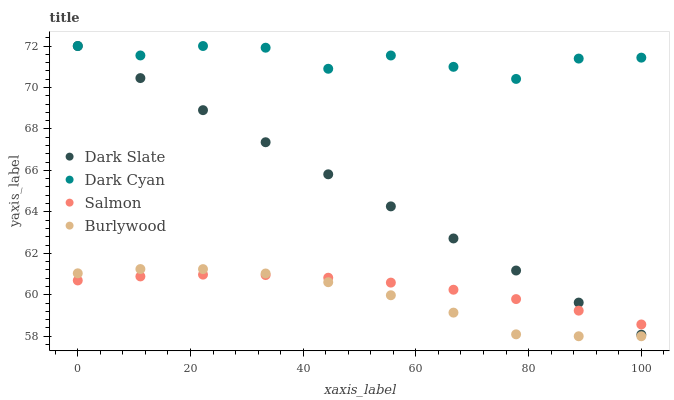Does Burlywood have the minimum area under the curve?
Answer yes or no. Yes. Does Dark Cyan have the maximum area under the curve?
Answer yes or no. Yes. Does Dark Slate have the minimum area under the curve?
Answer yes or no. No. Does Dark Slate have the maximum area under the curve?
Answer yes or no. No. Is Dark Slate the smoothest?
Answer yes or no. Yes. Is Dark Cyan the roughest?
Answer yes or no. Yes. Is Salmon the smoothest?
Answer yes or no. No. Is Salmon the roughest?
Answer yes or no. No. Does Burlywood have the lowest value?
Answer yes or no. Yes. Does Dark Slate have the lowest value?
Answer yes or no. No. Does Dark Slate have the highest value?
Answer yes or no. Yes. Does Salmon have the highest value?
Answer yes or no. No. Is Salmon less than Dark Cyan?
Answer yes or no. Yes. Is Dark Cyan greater than Burlywood?
Answer yes or no. Yes. Does Dark Cyan intersect Dark Slate?
Answer yes or no. Yes. Is Dark Cyan less than Dark Slate?
Answer yes or no. No. Is Dark Cyan greater than Dark Slate?
Answer yes or no. No. Does Salmon intersect Dark Cyan?
Answer yes or no. No. 